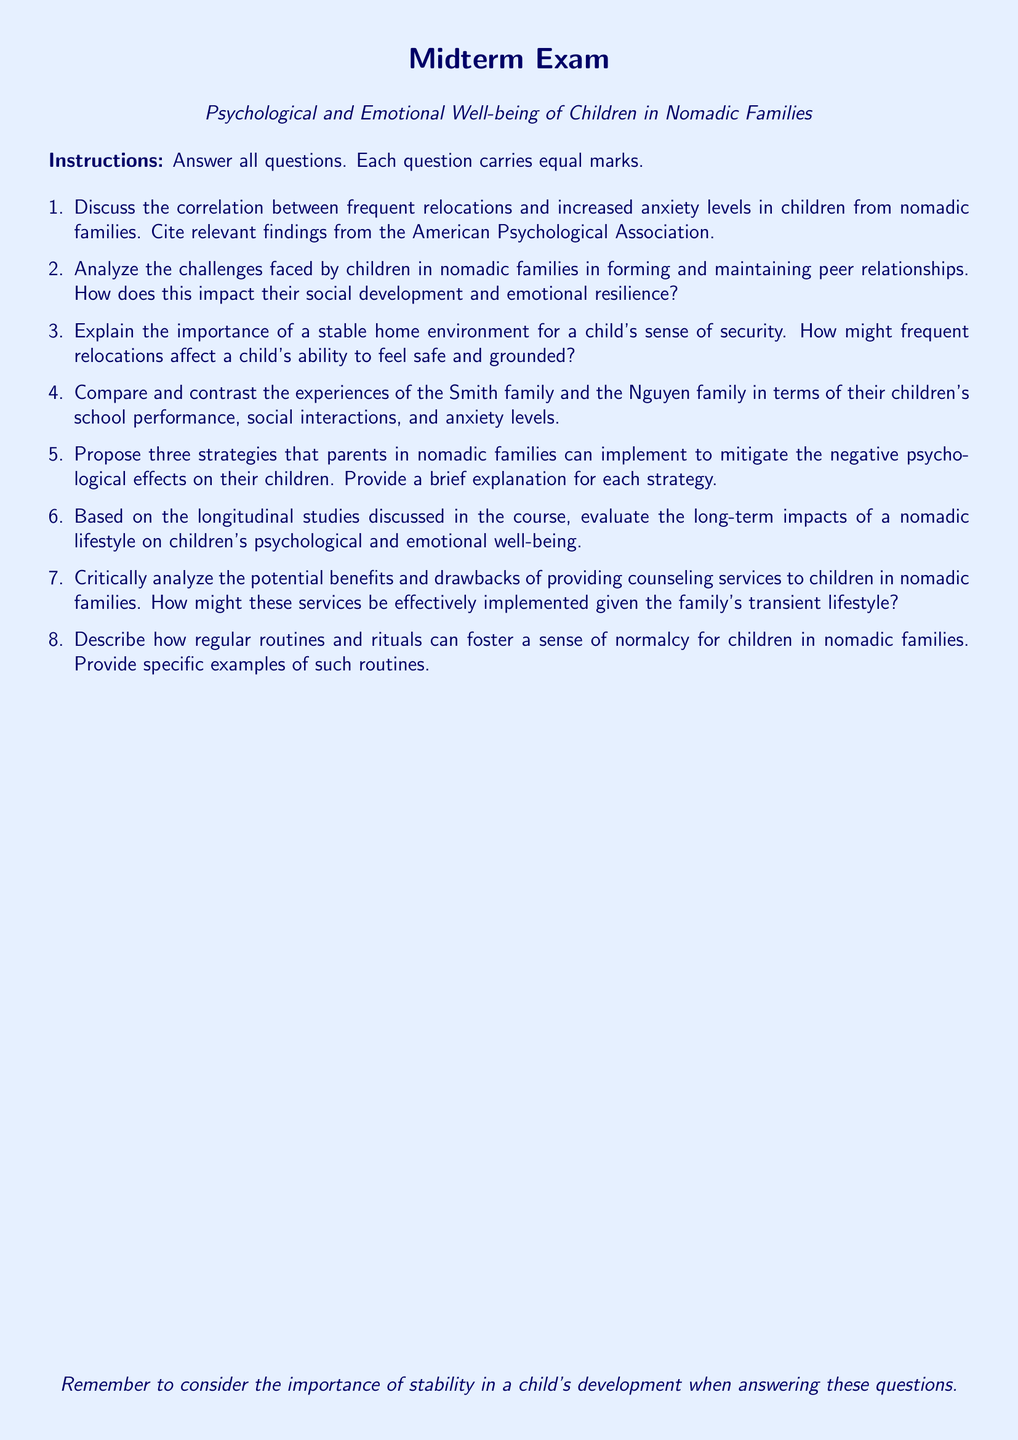what is the title of the document? The title of the document is the main subject of the midterm exam, which is specified in the header.
Answer: Psychological and Emotional Well-being of Children in Nomadic Families how many sections are in the exam? The number of sections corresponds to the number of questions listed in the exam.
Answer: Eight who authored the guidelines regarding anxiety levels in children? The document cites the American Psychological Association for the information on anxiety levels in children.
Answer: American Psychological Association what type of questions are included in the exam? The structure dictates the format of the questions, which are specified at the beginning of the exam.
Answer: Short-answer what is one emotional challenge nomadic children face? The emotional challenges relate to difficulties in social development due to frequent moves.
Answer: Maintaining peer relationships what is the primary focus of question 3? Question 3 specifically deals with the importance of a stable home environment for children.
Answer: Stable home environment what is asked regarding counseling services in the exam? The exam requests a critical analysis of the benefits and drawbacks of counseling for nomadic children.
Answer: Potential benefits and drawbacks how many strategies should be proposed in question 5? The document explicitly asks for three strategies to mitigate negative psychological effects.
Answer: Three 